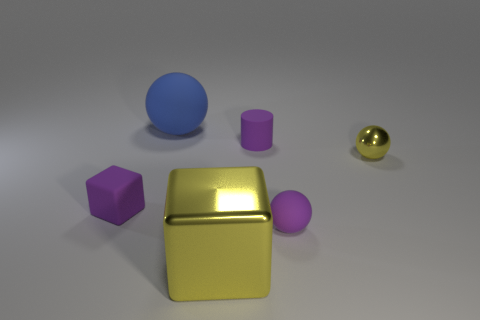There is a small object that is the same color as the big block; what is its shape?
Ensure brevity in your answer.  Sphere. There is a yellow thing to the right of the big metal thing; does it have the same shape as the big shiny thing?
Give a very brief answer. No. What number of objects are yellow metallic things or small purple matte objects on the left side of the small cylinder?
Keep it short and to the point. 3. There is a purple thing that is both on the right side of the blue thing and in front of the yellow ball; what is its size?
Ensure brevity in your answer.  Small. Are there more purple matte objects in front of the small yellow thing than blue matte balls in front of the large yellow cube?
Your answer should be very brief. Yes. Is the shape of the large metallic object the same as the tiny yellow metal thing that is right of the large blue thing?
Offer a very short reply. No. How many other things are there of the same shape as the big blue matte thing?
Provide a succinct answer. 2. What color is the tiny object that is both to the left of the purple matte ball and behind the tiny purple rubber block?
Offer a very short reply. Purple. What is the color of the large rubber thing?
Offer a terse response. Blue. Does the tiny purple block have the same material as the yellow thing that is behind the big yellow thing?
Provide a succinct answer. No. 